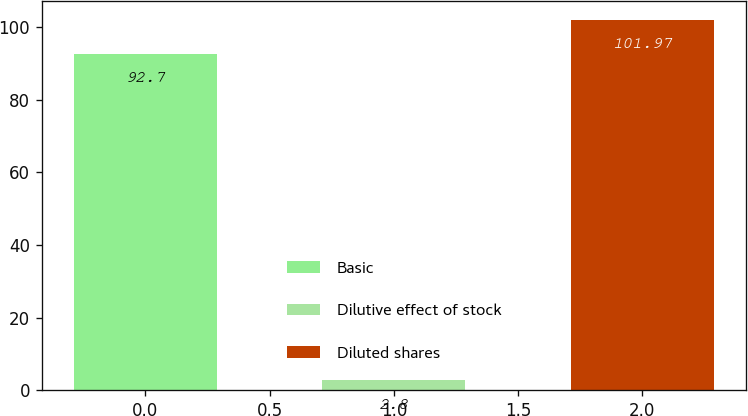<chart> <loc_0><loc_0><loc_500><loc_500><bar_chart><fcel>Basic<fcel>Dilutive effect of stock<fcel>Diluted shares<nl><fcel>92.7<fcel>2.8<fcel>101.97<nl></chart> 